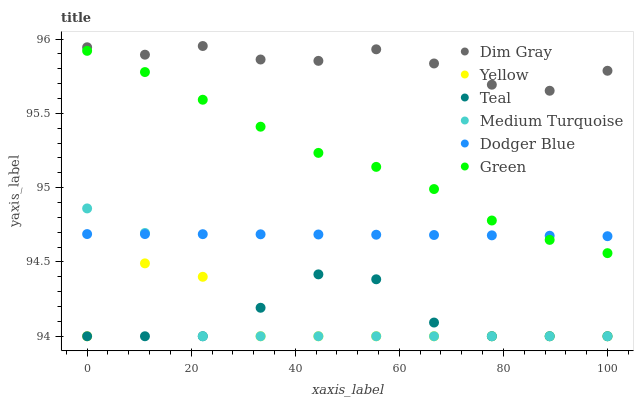Does Yellow have the minimum area under the curve?
Answer yes or no. Yes. Does Dim Gray have the maximum area under the curve?
Answer yes or no. Yes. Does Teal have the minimum area under the curve?
Answer yes or no. No. Does Teal have the maximum area under the curve?
Answer yes or no. No. Is Dodger Blue the smoothest?
Answer yes or no. Yes. Is Yellow the roughest?
Answer yes or no. Yes. Is Teal the smoothest?
Answer yes or no. No. Is Teal the roughest?
Answer yes or no. No. Does Teal have the lowest value?
Answer yes or no. Yes. Does Green have the lowest value?
Answer yes or no. No. Does Dim Gray have the highest value?
Answer yes or no. Yes. Does Yellow have the highest value?
Answer yes or no. No. Is Medium Turquoise less than Green?
Answer yes or no. Yes. Is Green greater than Teal?
Answer yes or no. Yes. Does Medium Turquoise intersect Dodger Blue?
Answer yes or no. Yes. Is Medium Turquoise less than Dodger Blue?
Answer yes or no. No. Is Medium Turquoise greater than Dodger Blue?
Answer yes or no. No. Does Medium Turquoise intersect Green?
Answer yes or no. No. 